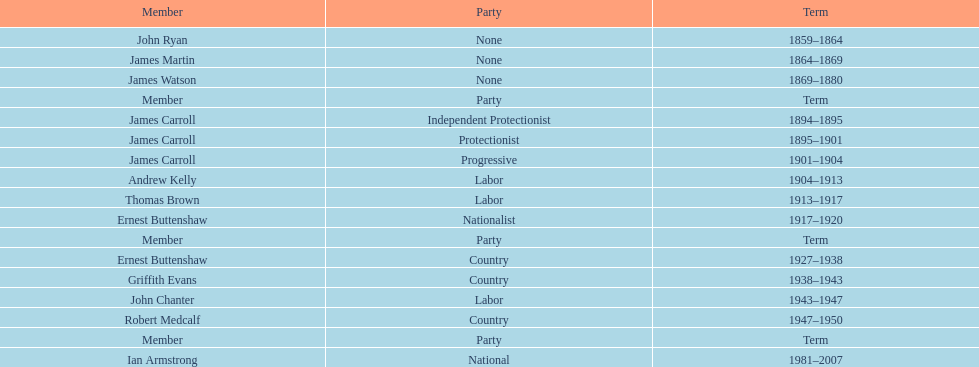Could you help me parse every detail presented in this table? {'header': ['Member', 'Party', 'Term'], 'rows': [['John Ryan', 'None', '1859–1864'], ['James Martin', 'None', '1864–1869'], ['James Watson', 'None', '1869–1880'], ['Member', 'Party', 'Term'], ['James Carroll', 'Independent Protectionist', '1894–1895'], ['James Carroll', 'Protectionist', '1895–1901'], ['James Carroll', 'Progressive', '1901–1904'], ['Andrew Kelly', 'Labor', '1904–1913'], ['Thomas Brown', 'Labor', '1913–1917'], ['Ernest Buttenshaw', 'Nationalist', '1917–1920'], ['Member', 'Party', 'Term'], ['Ernest Buttenshaw', 'Country', '1927–1938'], ['Griffith Evans', 'Country', '1938–1943'], ['John Chanter', 'Labor', '1943–1947'], ['Robert Medcalf', 'Country', '1947–1950'], ['Member', 'Party', 'Term'], ['Ian Armstrong', 'National', '1981–2007']]} What is the total number of service years for the members of the second version? 26. 